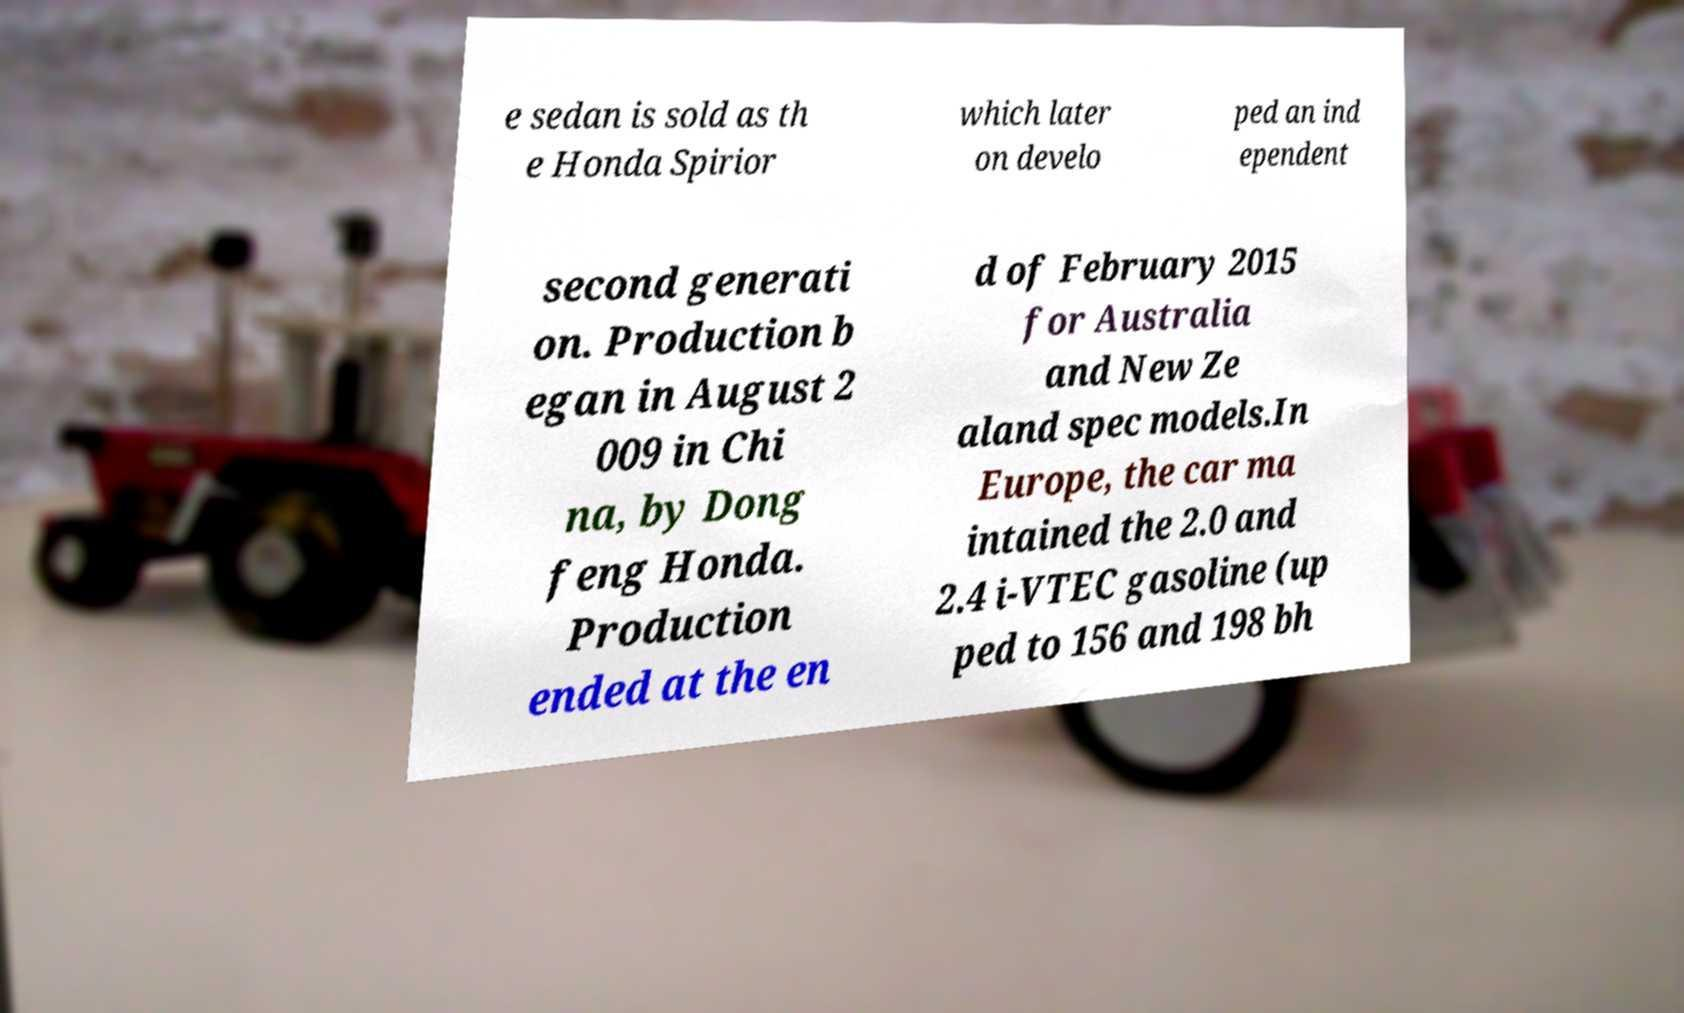Could you assist in decoding the text presented in this image and type it out clearly? e sedan is sold as th e Honda Spirior which later on develo ped an ind ependent second generati on. Production b egan in August 2 009 in Chi na, by Dong feng Honda. Production ended at the en d of February 2015 for Australia and New Ze aland spec models.In Europe, the car ma intained the 2.0 and 2.4 i-VTEC gasoline (up ped to 156 and 198 bh 